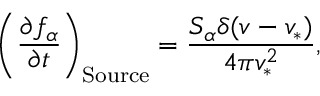<formula> <loc_0><loc_0><loc_500><loc_500>\left ( { \frac { \partial f _ { \alpha } } { \partial t } } \right ) _ { S o u r c e } = \frac { S _ { \alpha } \delta ( v - v _ { * } ) } { 4 \pi v _ { * } ^ { 2 } } ,</formula> 